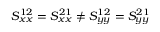Convert formula to latex. <formula><loc_0><loc_0><loc_500><loc_500>S _ { x x } ^ { 1 2 } = S _ { x x } ^ { 2 1 } \neq S _ { y y } ^ { 1 2 } = S _ { y y } ^ { 2 1 }</formula> 